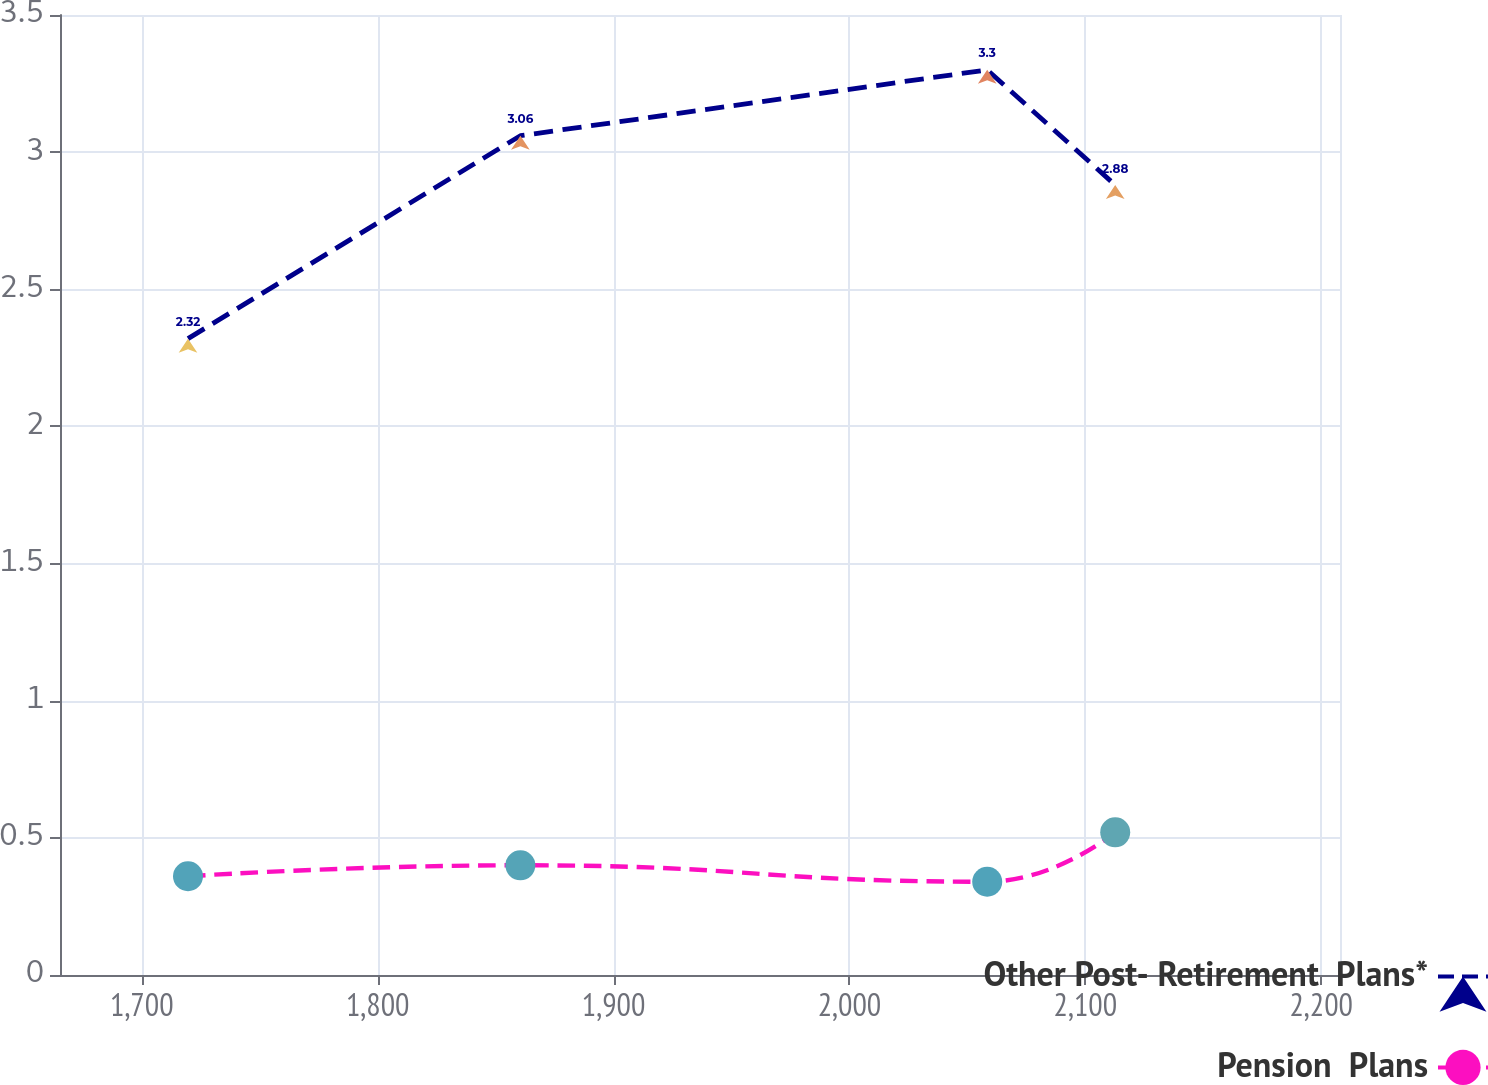Convert chart. <chart><loc_0><loc_0><loc_500><loc_500><line_chart><ecel><fcel>Other Post- Retirement  Plans*<fcel>Pension  Plans<nl><fcel>1719.6<fcel>2.32<fcel>0.36<nl><fcel>1860.5<fcel>3.06<fcel>0.4<nl><fcel>2058.4<fcel>3.3<fcel>0.34<nl><fcel>2112.66<fcel>2.88<fcel>0.52<nl><fcel>2262.21<fcel>4.15<fcel>0.44<nl></chart> 